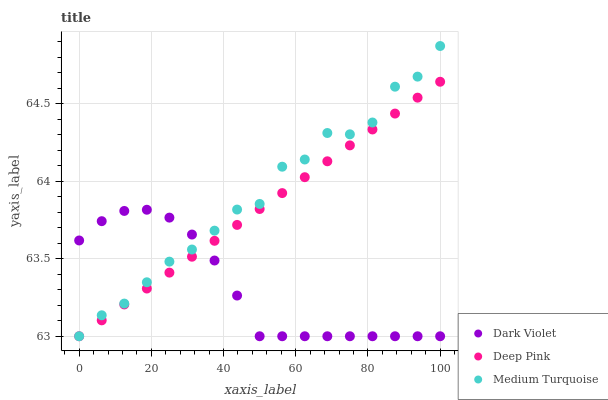Does Dark Violet have the minimum area under the curve?
Answer yes or no. Yes. Does Medium Turquoise have the maximum area under the curve?
Answer yes or no. Yes. Does Medium Turquoise have the minimum area under the curve?
Answer yes or no. No. Does Dark Violet have the maximum area under the curve?
Answer yes or no. No. Is Deep Pink the smoothest?
Answer yes or no. Yes. Is Medium Turquoise the roughest?
Answer yes or no. Yes. Is Dark Violet the smoothest?
Answer yes or no. No. Is Dark Violet the roughest?
Answer yes or no. No. Does Deep Pink have the lowest value?
Answer yes or no. Yes. Does Medium Turquoise have the highest value?
Answer yes or no. Yes. Does Dark Violet have the highest value?
Answer yes or no. No. Does Medium Turquoise intersect Deep Pink?
Answer yes or no. Yes. Is Medium Turquoise less than Deep Pink?
Answer yes or no. No. Is Medium Turquoise greater than Deep Pink?
Answer yes or no. No. 